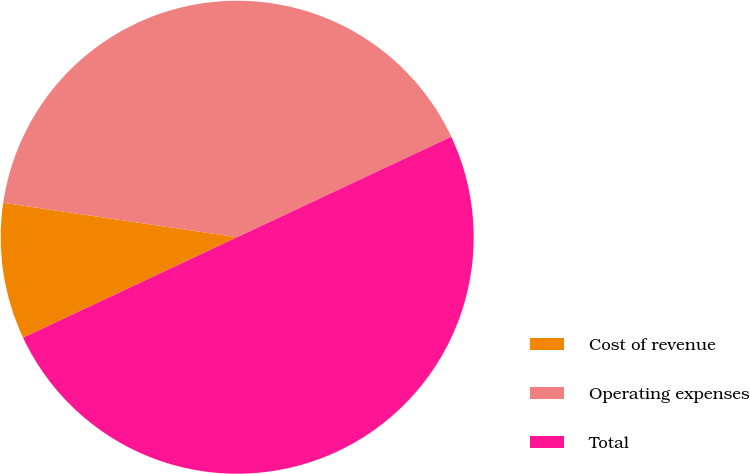Convert chart. <chart><loc_0><loc_0><loc_500><loc_500><pie_chart><fcel>Cost of revenue<fcel>Operating expenses<fcel>Total<nl><fcel>9.31%<fcel>40.69%<fcel>50.0%<nl></chart> 